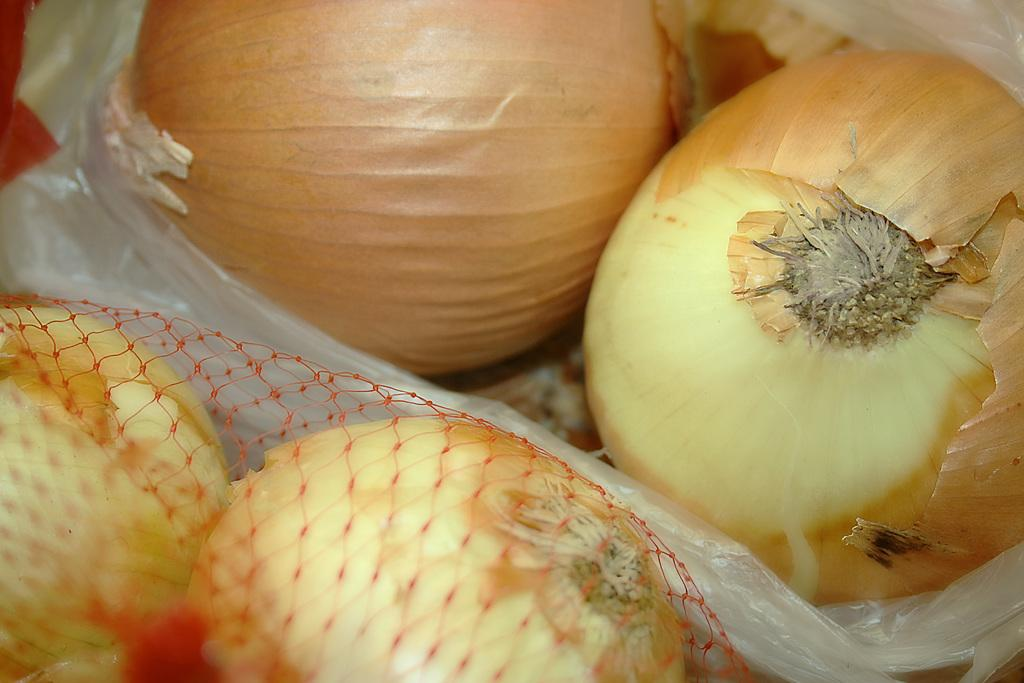What type of vegetable is present in the image? There are onions in the image. Are all the onions visible or are some covered? Some onions are covered in the image. How are the visible onions stored or displayed? Some onions are in a red color net. Can you see the eye of the creature in the image? There is no creature present in the image, so it is not possible to see its eye. 